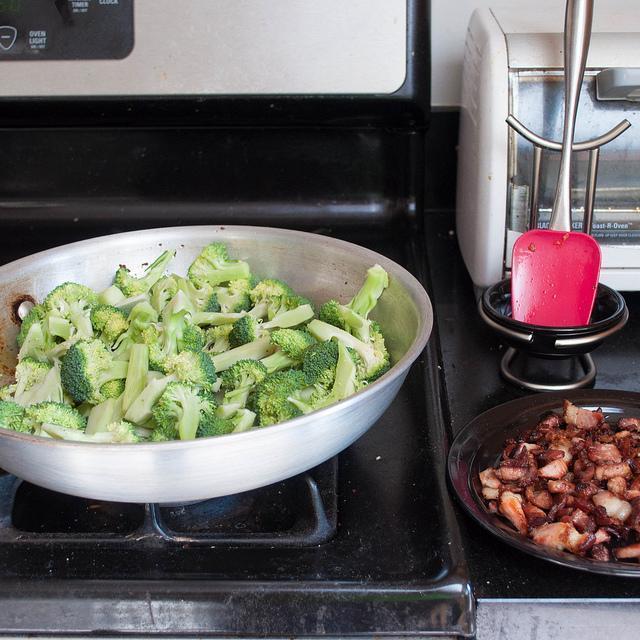Does the caption "The broccoli is on the oven." correctly depict the image?
Answer yes or no. Yes. 